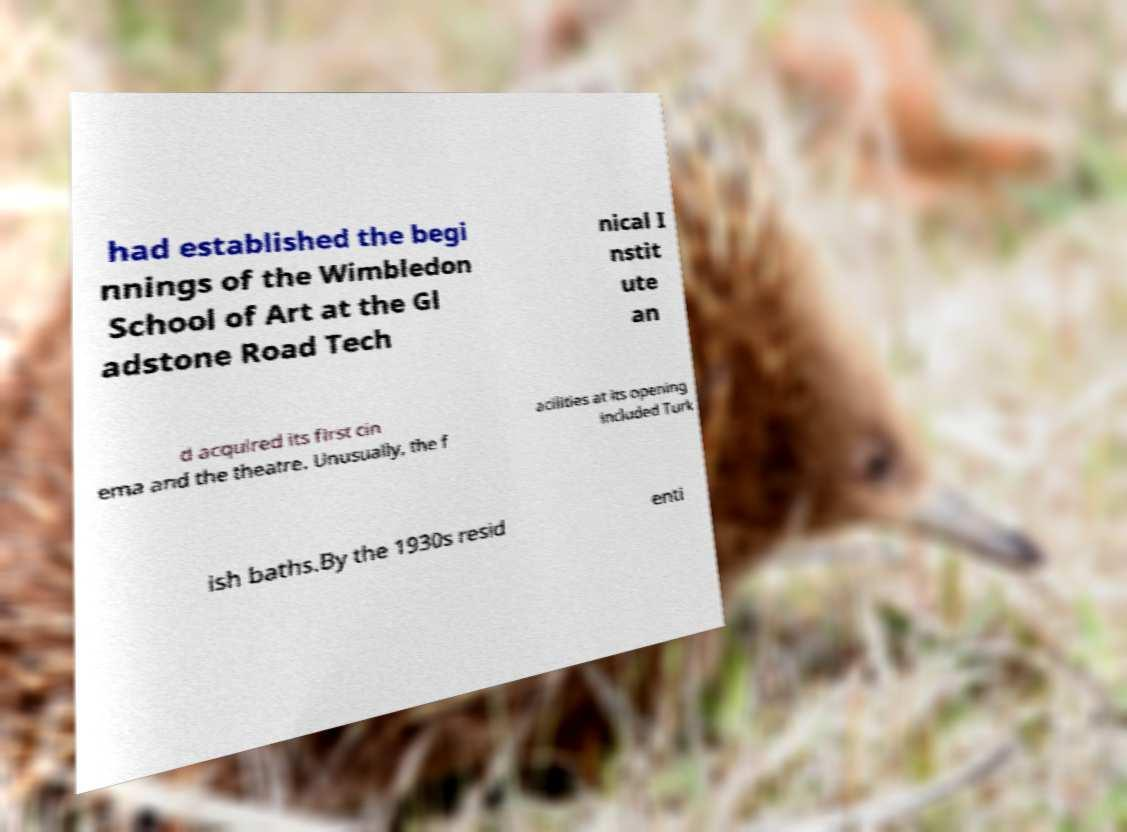What messages or text are displayed in this image? I need them in a readable, typed format. had established the begi nnings of the Wimbledon School of Art at the Gl adstone Road Tech nical I nstit ute an d acquired its first cin ema and the theatre. Unusually, the f acilities at its opening included Turk ish baths.By the 1930s resid enti 